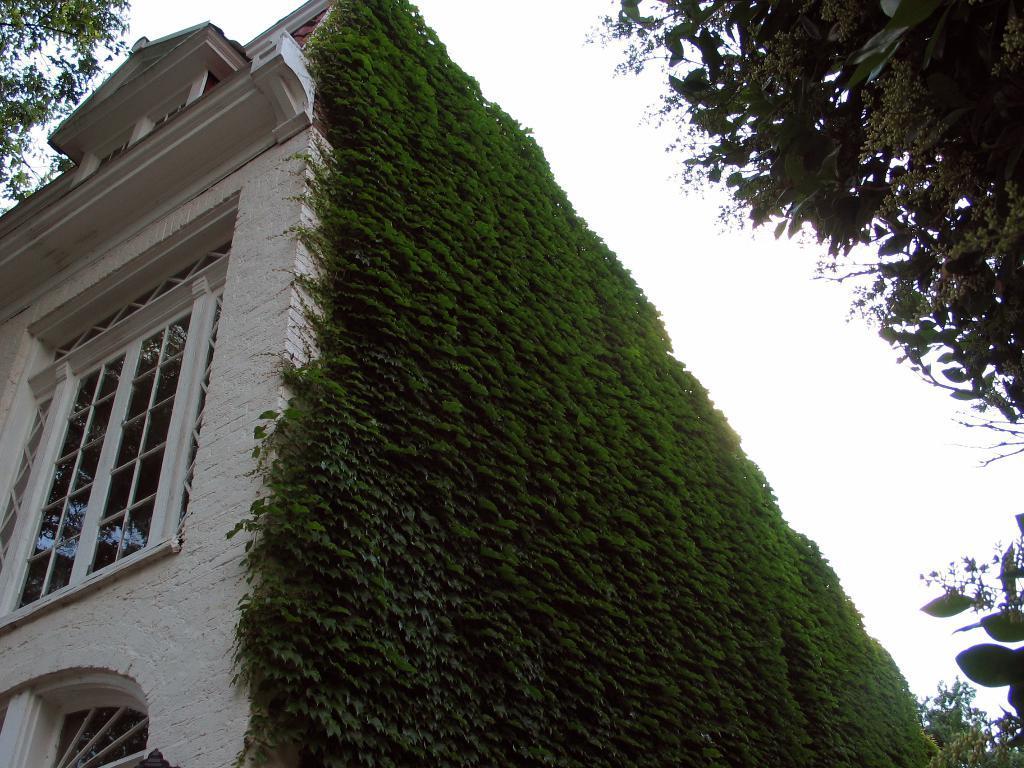Could you give a brief overview of what you see in this image? In this picture we can see a brown color building with glass windows. Beside there is are some green vertical garden plants on the wall. On the right side there is a tree. 